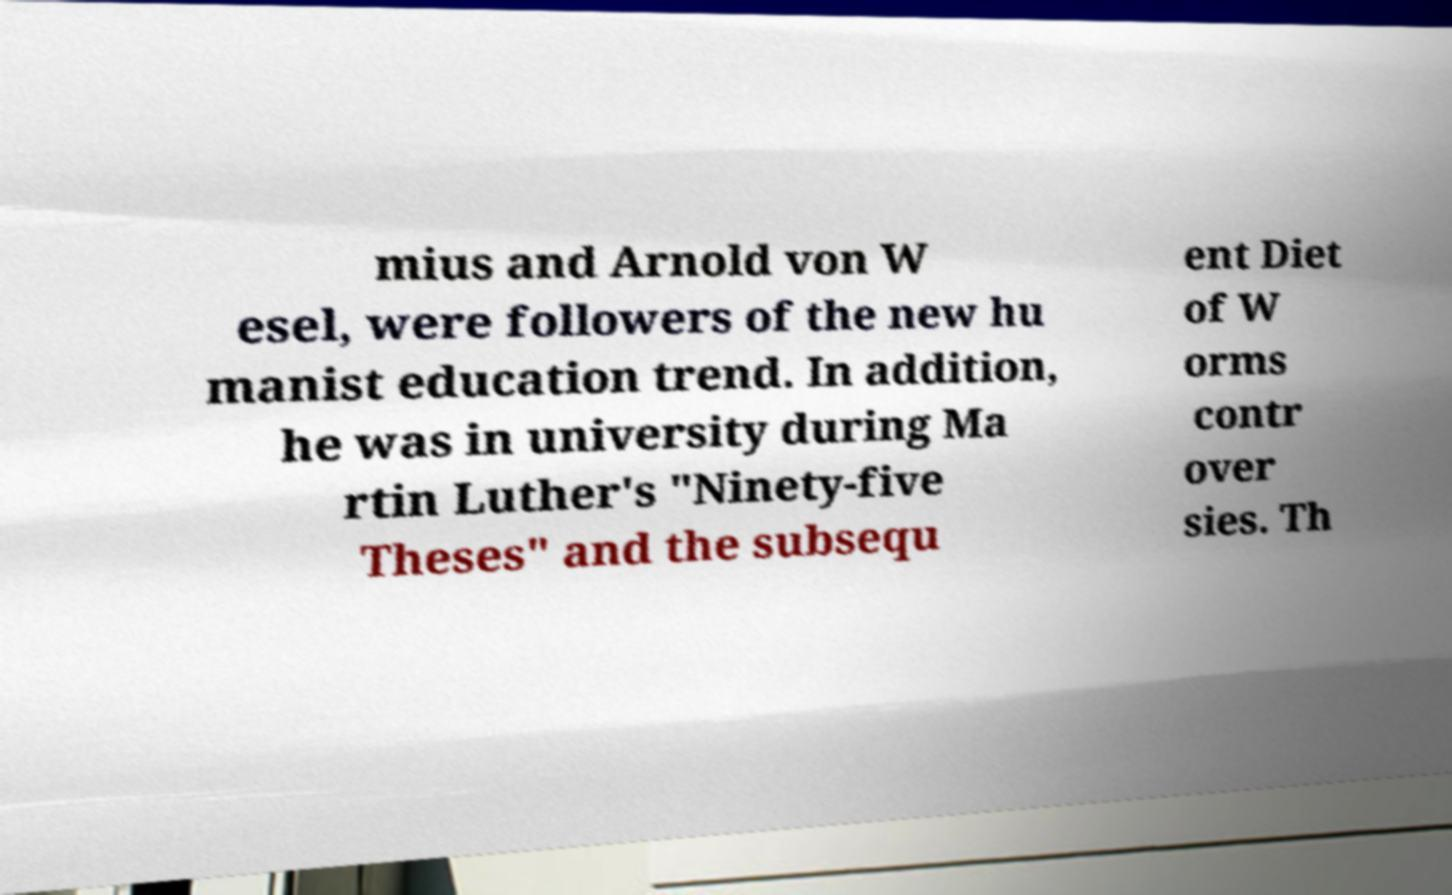Please identify and transcribe the text found in this image. mius and Arnold von W esel, were followers of the new hu manist education trend. In addition, he was in university during Ma rtin Luther's "Ninety-five Theses" and the subsequ ent Diet of W orms contr over sies. Th 